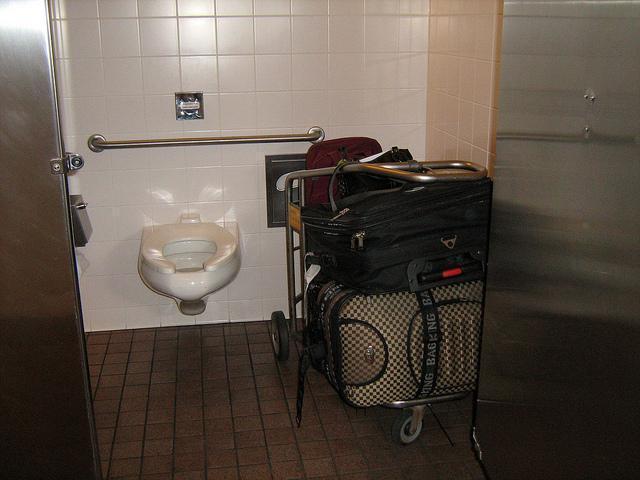Where is this bathroom likely to be found in?
From the following four choices, select the correct answer to address the question.
Options: Airport, shopping mall, school, theater. Airport. 